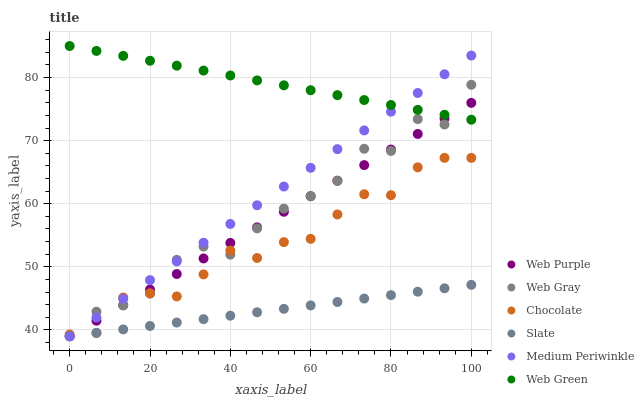Does Slate have the minimum area under the curve?
Answer yes or no. Yes. Does Web Green have the maximum area under the curve?
Answer yes or no. Yes. Does Medium Periwinkle have the minimum area under the curve?
Answer yes or no. No. Does Medium Periwinkle have the maximum area under the curve?
Answer yes or no. No. Is Slate the smoothest?
Answer yes or no. Yes. Is Web Gray the roughest?
Answer yes or no. Yes. Is Medium Periwinkle the smoothest?
Answer yes or no. No. Is Medium Periwinkle the roughest?
Answer yes or no. No. Does Web Gray have the lowest value?
Answer yes or no. Yes. Does Web Green have the lowest value?
Answer yes or no. No. Does Web Green have the highest value?
Answer yes or no. Yes. Does Medium Periwinkle have the highest value?
Answer yes or no. No. Is Slate less than Web Green?
Answer yes or no. Yes. Is Web Green greater than Slate?
Answer yes or no. Yes. Does Medium Periwinkle intersect Web Gray?
Answer yes or no. Yes. Is Medium Periwinkle less than Web Gray?
Answer yes or no. No. Is Medium Periwinkle greater than Web Gray?
Answer yes or no. No. Does Slate intersect Web Green?
Answer yes or no. No. 